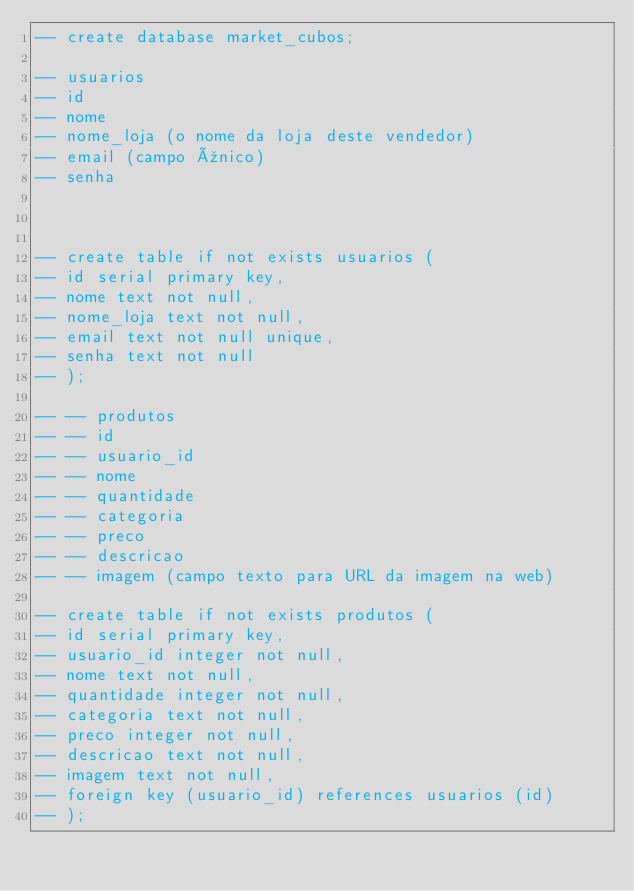<code> <loc_0><loc_0><loc_500><loc_500><_SQL_>-- create database market_cubos;

-- usuarios
-- id
-- nome
-- nome_loja (o nome da loja deste vendedor)
-- email (campo único)
-- senha



-- create table if not exists usuarios (
-- id serial primary key,
-- nome text not null,
-- nome_loja text not null,
-- email text not null unique,
-- senha text not null
-- );

-- -- produtos
-- -- id
-- -- usuario_id
-- -- nome
-- -- quantidade
-- -- categoria
-- -- preco
-- -- descricao
-- -- imagem (campo texto para URL da imagem na web)

-- create table if not exists produtos (
-- id serial primary key,
-- usuario_id integer not null,
-- nome text not null,
-- quantidade integer not null,
-- categoria text not null,
-- preco integer not null,
-- descricao text not null,
-- imagem text not null,
-- foreign key (usuario_id) references usuarios (id)
-- );





</code> 